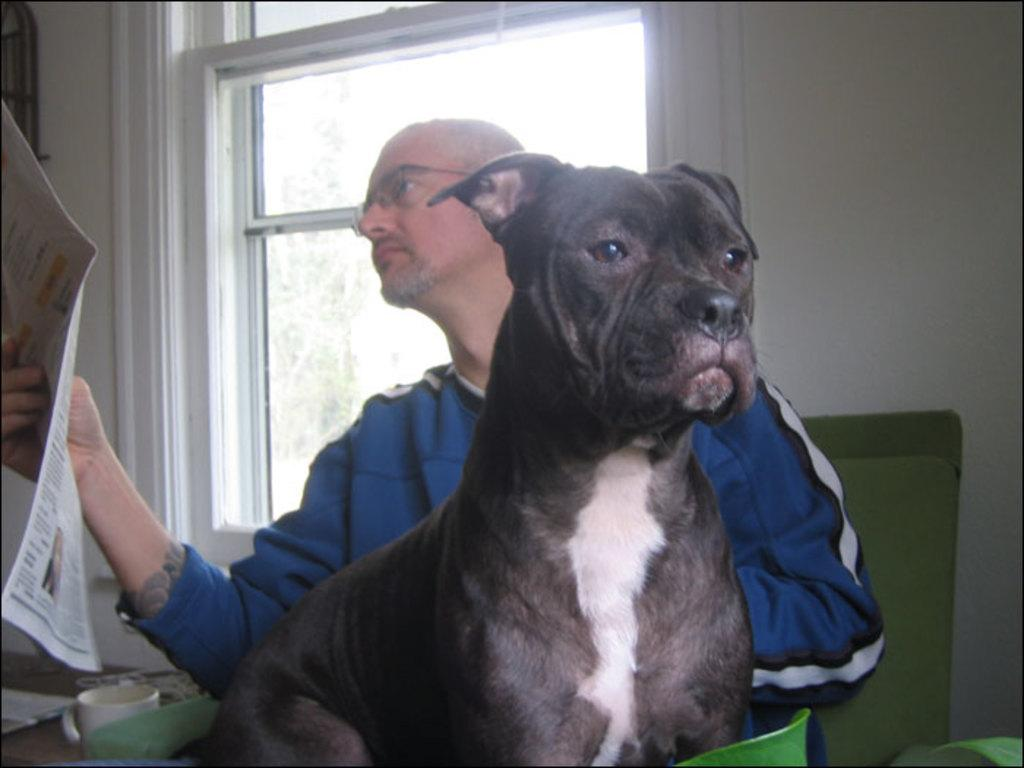Who is the main subject in the image? There is a man in the image. What is the man doing in the image? The man is sitting on a chair and holding a newspaper in his right hand. What can be seen on the man's right side? There is a window on the man's right side. What is present on the man's left side? There is a dog on the man's left side. What type of oranges is the governor eating during the recess in the image? There is no governor or oranges present in the image, and there is no mention of a recess. 